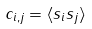Convert formula to latex. <formula><loc_0><loc_0><loc_500><loc_500>c _ { i , j } = \langle s _ { i } s _ { j } \rangle</formula> 